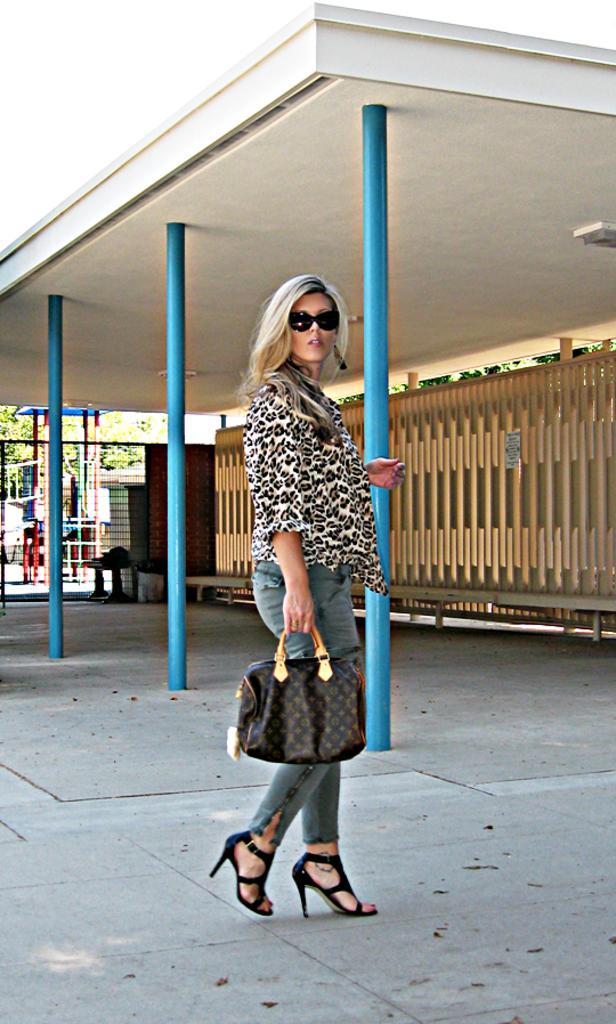Describe this image in one or two sentences. In the middle of the background, there is a woman standing and holding a hand bag, who´is wearing top and jeans and a goggle black in color. On the top there is a wall of white in color and a poles of blue in color visible. In the background middle, tree is visible. This image is taken during day time from outside. 